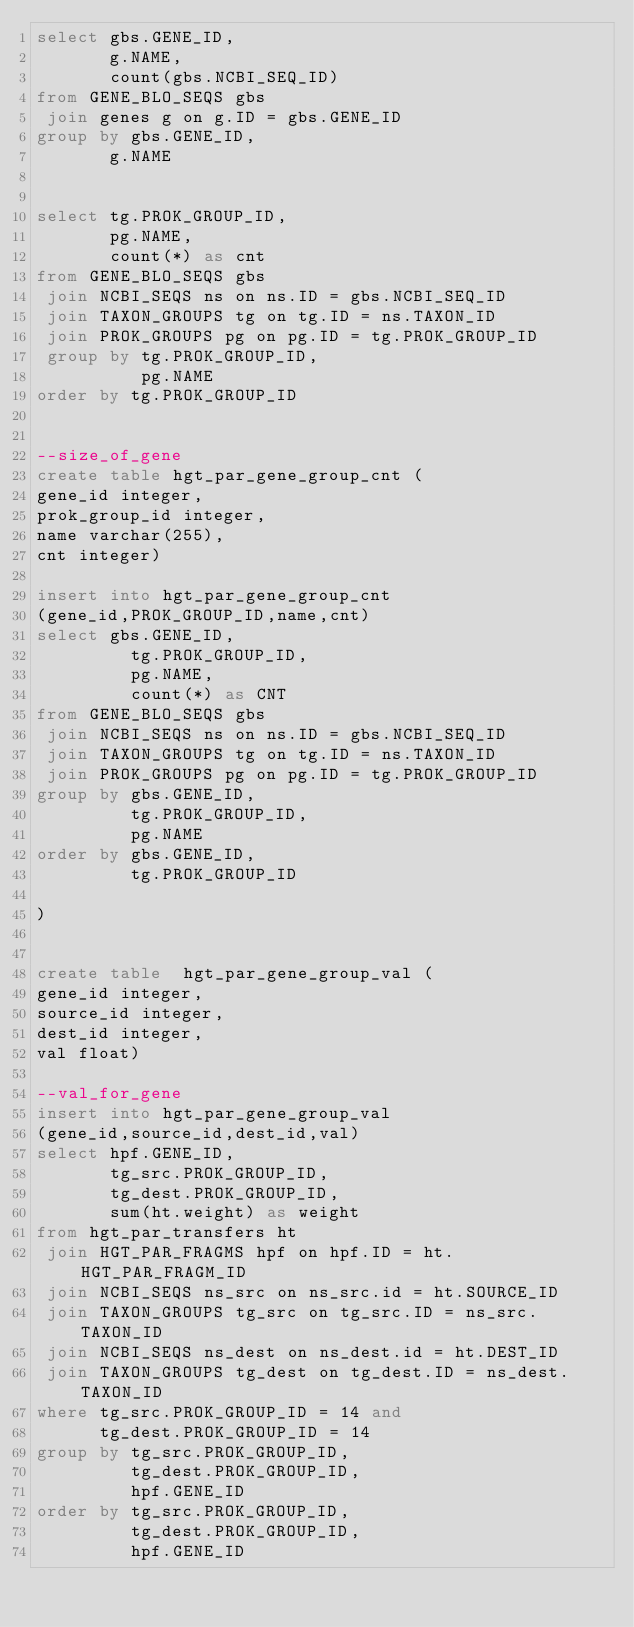<code> <loc_0><loc_0><loc_500><loc_500><_SQL_>select gbs.GENE_ID,
       g.NAME,
       count(gbs.NCBI_SEQ_ID)
from GENE_BLO_SEQS gbs
 join genes g on g.ID = gbs.GENE_ID
group by gbs.GENE_ID,
       g.NAME


select tg.PROK_GROUP_ID,
       pg.NAME,
       count(*) as cnt
from GENE_BLO_SEQS gbs
 join NCBI_SEQS ns on ns.ID = gbs.NCBI_SEQ_ID
 join TAXON_GROUPS tg on tg.ID = ns.TAXON_ID
 join PROK_GROUPS pg on pg.ID = tg.PROK_GROUP_ID
 group by tg.PROK_GROUP_ID,
          pg.NAME
order by tg.PROK_GROUP_ID


--size_of_gene
create table hgt_par_gene_group_cnt (
gene_id integer,
prok_group_id integer,
name varchar(255),
cnt integer)

insert into hgt_par_gene_group_cnt
(gene_id,PROK_GROUP_ID,name,cnt)
select gbs.GENE_ID,
         tg.PROK_GROUP_ID,
         pg.NAME,
         count(*) as CNT
from GENE_BLO_SEQS gbs
 join NCBI_SEQS ns on ns.ID = gbs.NCBI_SEQ_ID
 join TAXON_GROUPS tg on tg.ID = ns.TAXON_ID
 join PROK_GROUPS pg on pg.ID = tg.PROK_GROUP_ID
group by gbs.GENE_ID,
         tg.PROK_GROUP_ID,
         pg.NAME
order by gbs.GENE_ID,
         tg.PROK_GROUP_ID

)
       

create table  hgt_par_gene_group_val (
gene_id integer,
source_id integer,
dest_id integer,
val float)

--val_for_gene
insert into hgt_par_gene_group_val 
(gene_id,source_id,dest_id,val)
select hpf.GENE_ID,
       tg_src.PROK_GROUP_ID,
       tg_dest.PROK_GROUP_ID,
       sum(ht.weight) as weight
from hgt_par_transfers ht
 join HGT_PAR_FRAGMS hpf on hpf.ID = ht.HGT_PAR_FRAGM_ID
 join NCBI_SEQS ns_src on ns_src.id = ht.SOURCE_ID
 join TAXON_GROUPS tg_src on tg_src.ID = ns_src.TAXON_ID
 join NCBI_SEQS ns_dest on ns_dest.id = ht.DEST_ID
 join TAXON_GROUPS tg_dest on tg_dest.ID = ns_dest.TAXON_ID
where tg_src.PROK_GROUP_ID = 14 and
      tg_dest.PROK_GROUP_ID = 14 
group by tg_src.PROK_GROUP_ID,
         tg_dest.PROK_GROUP_ID,
         hpf.GENE_ID
order by tg_src.PROK_GROUP_ID,
         tg_dest.PROK_GROUP_ID,
         hpf.GENE_ID
       

</code> 